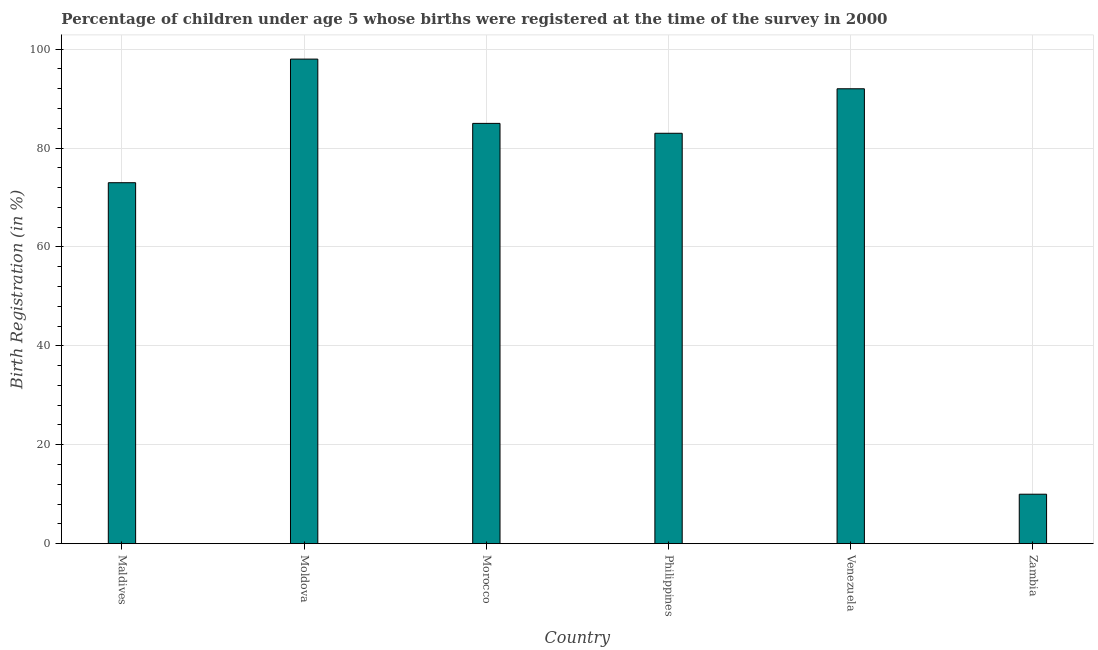What is the title of the graph?
Your answer should be compact. Percentage of children under age 5 whose births were registered at the time of the survey in 2000. What is the label or title of the X-axis?
Make the answer very short. Country. What is the label or title of the Y-axis?
Give a very brief answer. Birth Registration (in %). What is the birth registration in Zambia?
Offer a very short reply. 10. Across all countries, what is the maximum birth registration?
Give a very brief answer. 98. In which country was the birth registration maximum?
Your answer should be compact. Moldova. In which country was the birth registration minimum?
Keep it short and to the point. Zambia. What is the sum of the birth registration?
Keep it short and to the point. 441. What is the difference between the birth registration in Philippines and Zambia?
Provide a succinct answer. 73. What is the average birth registration per country?
Provide a short and direct response. 73.5. In how many countries, is the birth registration greater than 16 %?
Make the answer very short. 5. What is the ratio of the birth registration in Moldova to that in Morocco?
Make the answer very short. 1.15. Is the difference between the birth registration in Morocco and Venezuela greater than the difference between any two countries?
Provide a succinct answer. No. Is the sum of the birth registration in Venezuela and Zambia greater than the maximum birth registration across all countries?
Your response must be concise. Yes. What is the difference between the highest and the lowest birth registration?
Offer a terse response. 88. In how many countries, is the birth registration greater than the average birth registration taken over all countries?
Your answer should be very brief. 4. How many bars are there?
Provide a short and direct response. 6. How many countries are there in the graph?
Your answer should be compact. 6. What is the Birth Registration (in %) of Maldives?
Provide a succinct answer. 73. What is the Birth Registration (in %) of Moldova?
Keep it short and to the point. 98. What is the Birth Registration (in %) in Morocco?
Your answer should be very brief. 85. What is the Birth Registration (in %) in Philippines?
Your response must be concise. 83. What is the Birth Registration (in %) of Venezuela?
Ensure brevity in your answer.  92. What is the difference between the Birth Registration (in %) in Maldives and Philippines?
Offer a very short reply. -10. What is the difference between the Birth Registration (in %) in Maldives and Venezuela?
Give a very brief answer. -19. What is the difference between the Birth Registration (in %) in Moldova and Morocco?
Your answer should be compact. 13. What is the difference between the Birth Registration (in %) in Moldova and Philippines?
Offer a terse response. 15. What is the difference between the Birth Registration (in %) in Morocco and Philippines?
Offer a terse response. 2. What is the difference between the Birth Registration (in %) in Philippines and Venezuela?
Ensure brevity in your answer.  -9. What is the difference between the Birth Registration (in %) in Philippines and Zambia?
Ensure brevity in your answer.  73. What is the ratio of the Birth Registration (in %) in Maldives to that in Moldova?
Your answer should be compact. 0.74. What is the ratio of the Birth Registration (in %) in Maldives to that in Morocco?
Your response must be concise. 0.86. What is the ratio of the Birth Registration (in %) in Maldives to that in Philippines?
Your response must be concise. 0.88. What is the ratio of the Birth Registration (in %) in Maldives to that in Venezuela?
Offer a terse response. 0.79. What is the ratio of the Birth Registration (in %) in Maldives to that in Zambia?
Keep it short and to the point. 7.3. What is the ratio of the Birth Registration (in %) in Moldova to that in Morocco?
Give a very brief answer. 1.15. What is the ratio of the Birth Registration (in %) in Moldova to that in Philippines?
Your answer should be very brief. 1.18. What is the ratio of the Birth Registration (in %) in Moldova to that in Venezuela?
Ensure brevity in your answer.  1.06. What is the ratio of the Birth Registration (in %) in Moldova to that in Zambia?
Make the answer very short. 9.8. What is the ratio of the Birth Registration (in %) in Morocco to that in Venezuela?
Ensure brevity in your answer.  0.92. What is the ratio of the Birth Registration (in %) in Philippines to that in Venezuela?
Your answer should be compact. 0.9. 